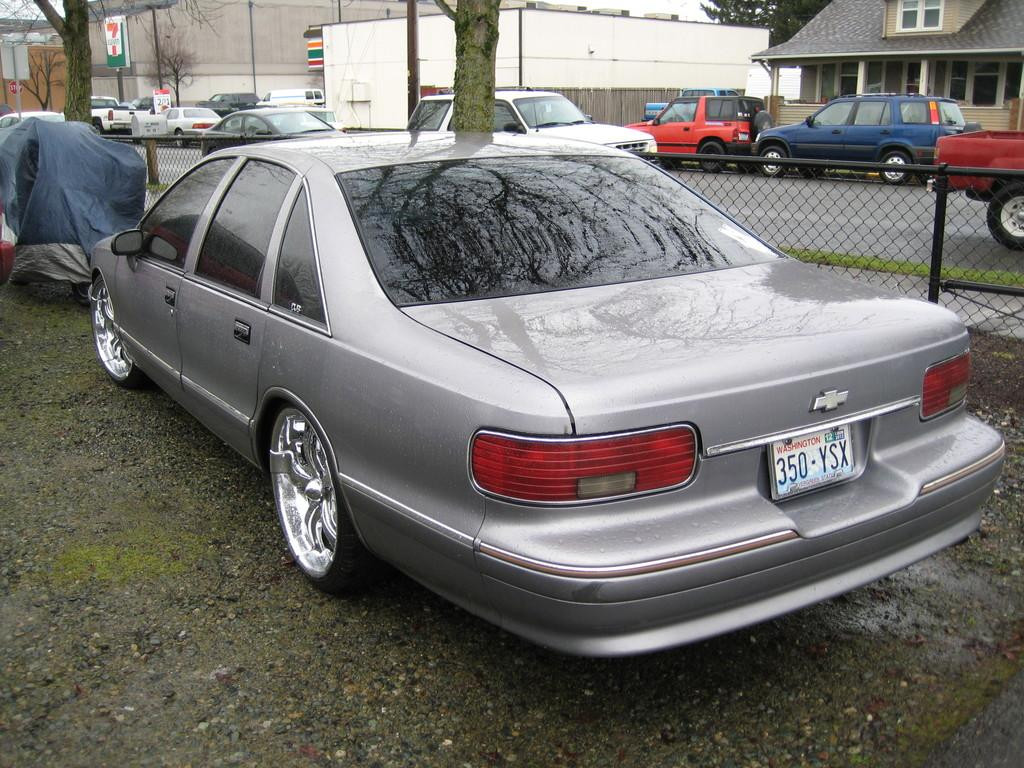What color is the vehicle on the road in the image? The vehicle on the road is gray. What is located beside the vehicle? There is an iron fence beside the vehicle. What can be seen in the background of the image? There are vehicles, buildings, and trees visible in the background. Can you read the list of ingredients for the clover in the image? There is no clover or list of ingredients present in the image. 